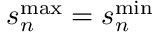Convert formula to latex. <formula><loc_0><loc_0><loc_500><loc_500>s _ { n } ^ { \max } = s _ { n } ^ { \min }</formula> 